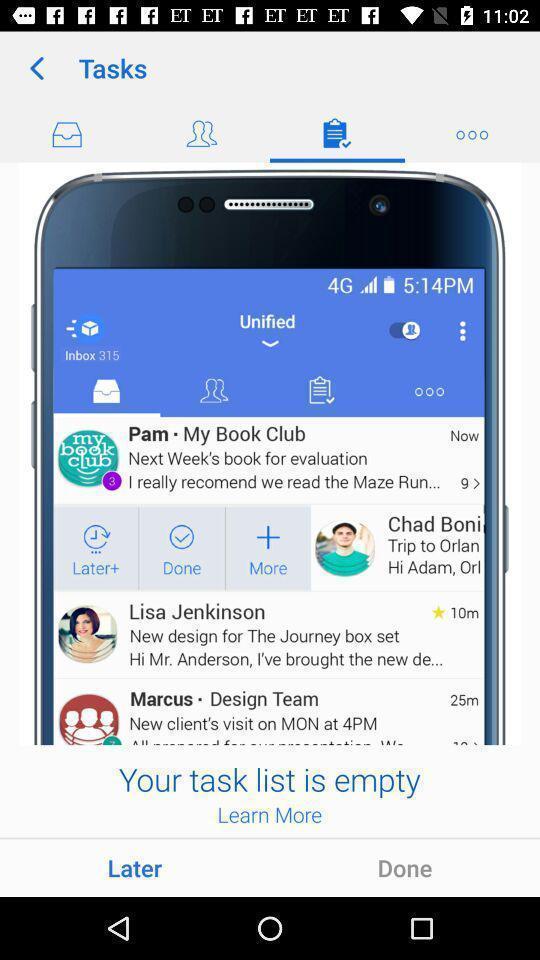Explain the elements present in this screenshot. Screen shows task options. 